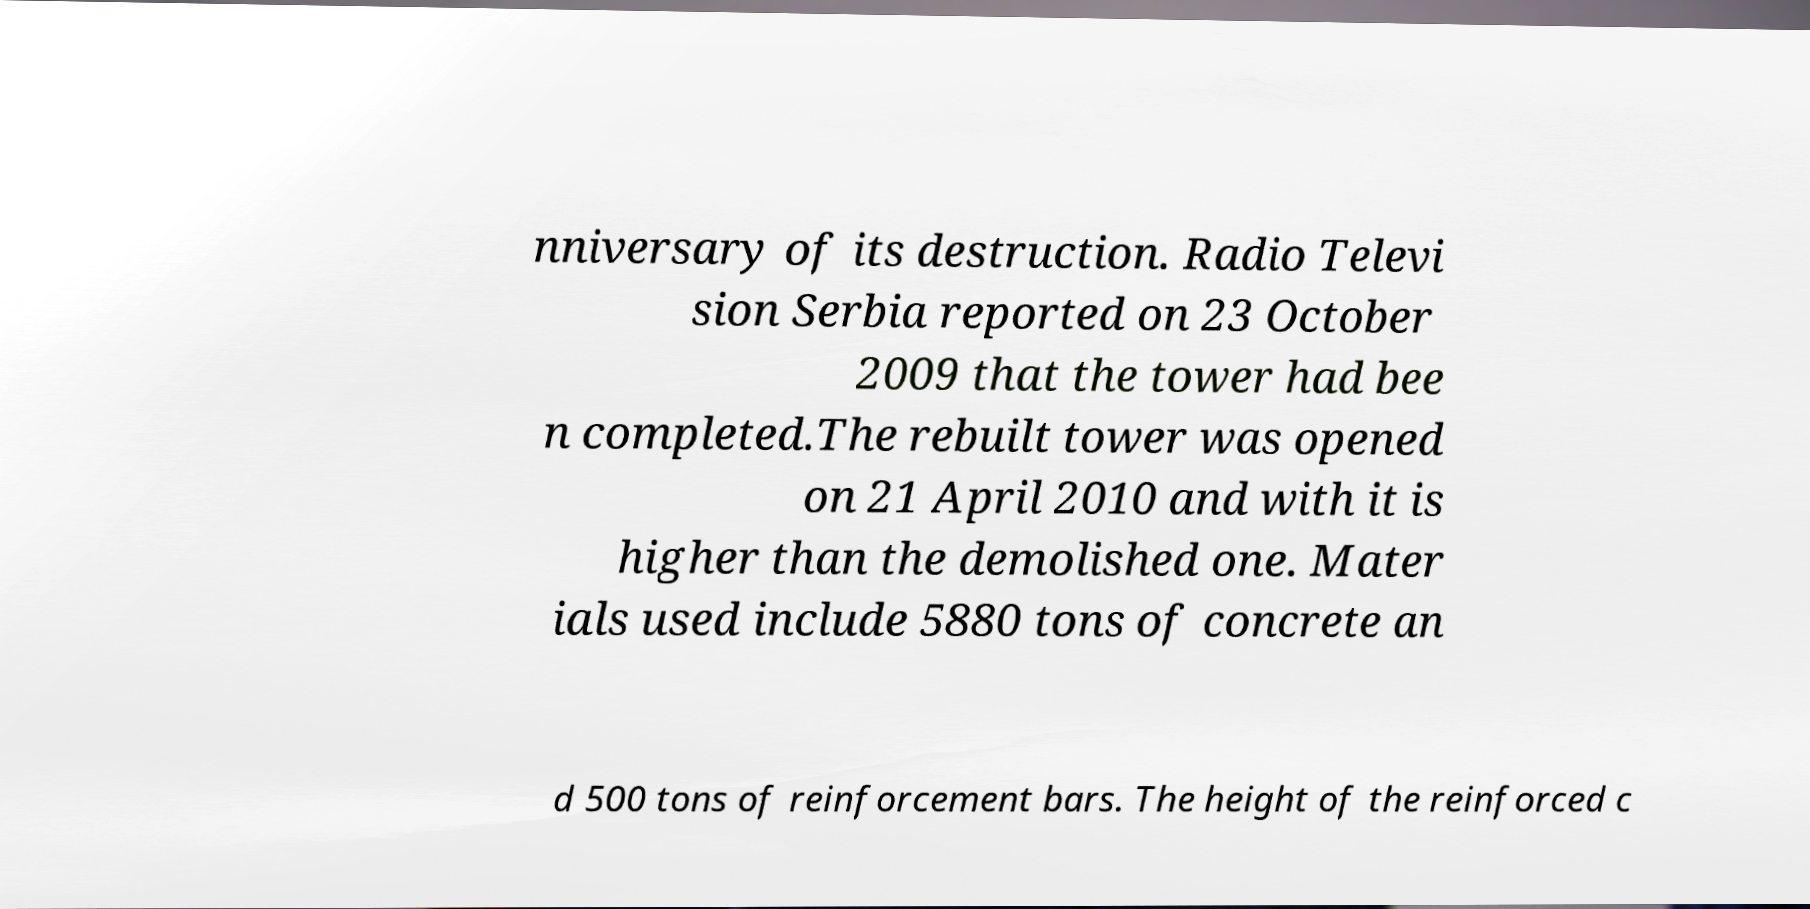I need the written content from this picture converted into text. Can you do that? nniversary of its destruction. Radio Televi sion Serbia reported on 23 October 2009 that the tower had bee n completed.The rebuilt tower was opened on 21 April 2010 and with it is higher than the demolished one. Mater ials used include 5880 tons of concrete an d 500 tons of reinforcement bars. The height of the reinforced c 